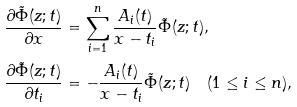<formula> <loc_0><loc_0><loc_500><loc_500>\frac { \partial \tilde { \Phi } ( z ; t ) } { \partial x } & = \sum _ { i = 1 } ^ { n } \frac { A _ { i } ( t ) } { x - t _ { i } } \tilde { \Phi } ( z ; t ) , \\ \frac { \partial \tilde { \Phi } ( z ; t ) } { \partial t _ { i } } & = - \frac { A _ { i } ( t ) } { x - t _ { i } } \tilde { \Phi } ( z ; t ) \quad ( 1 \leq i \leq n ) ,</formula> 